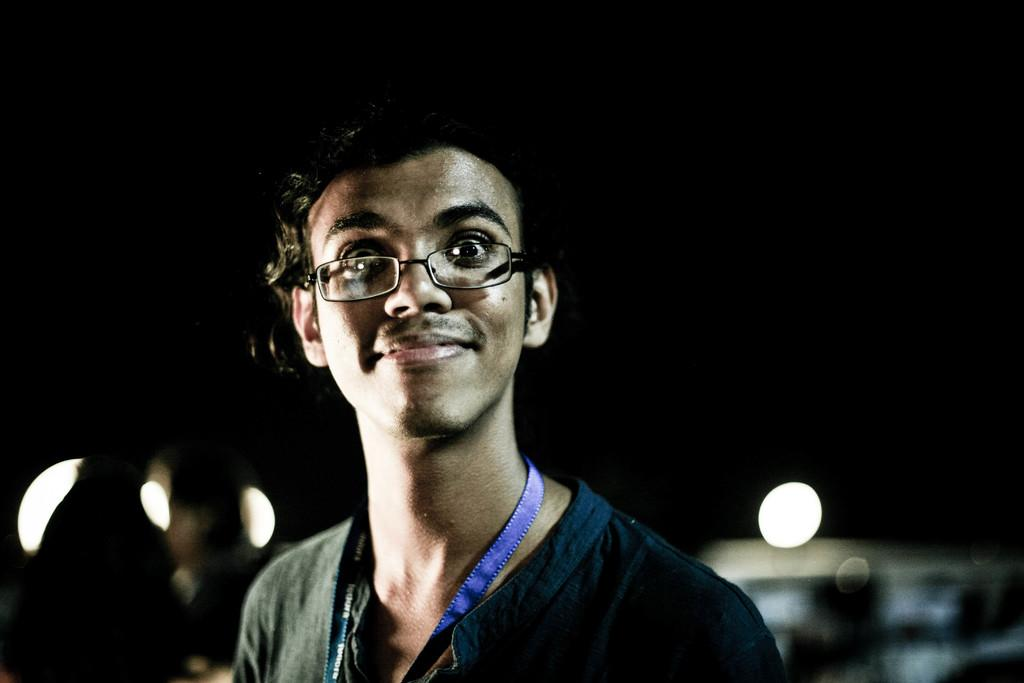Who or what is the main subject of the image? There is a person in the image. Can you describe the person's attire? The person is wearing clothes. Are there any accessories visible on the person? Yes, the person is wearing spectacles. What type of marble is the person holding in the image? There is no marble present in the image; the person is wearing spectacles and clothes. 